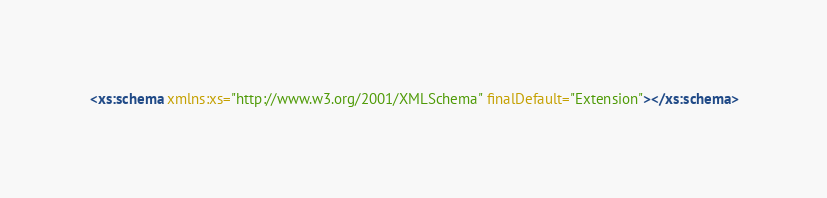<code> <loc_0><loc_0><loc_500><loc_500><_XML_><xs:schema xmlns:xs="http://www.w3.org/2001/XMLSchema" finalDefault="Extension"></xs:schema>
</code> 